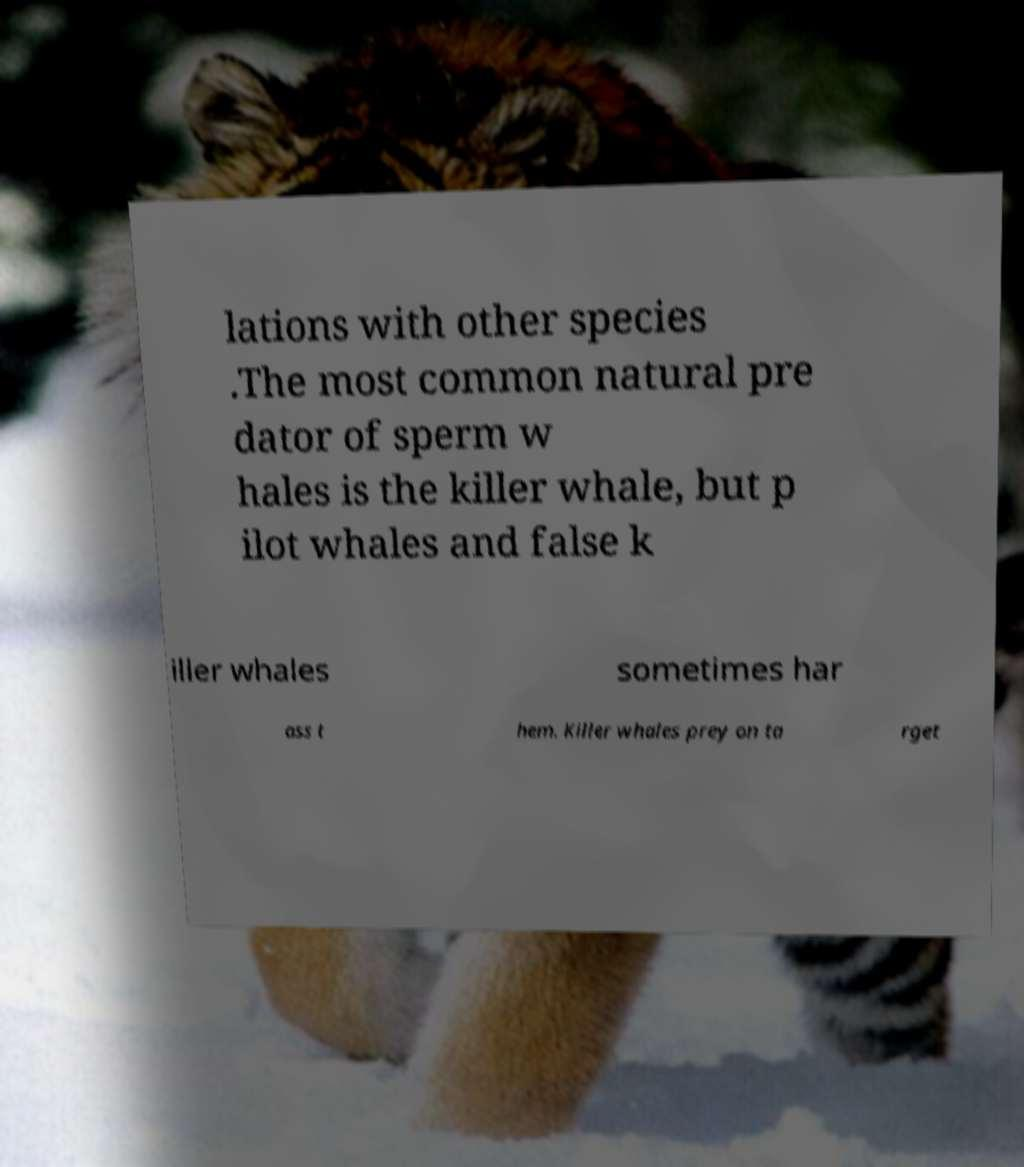What messages or text are displayed in this image? I need them in a readable, typed format. lations with other species .The most common natural pre dator of sperm w hales is the killer whale, but p ilot whales and false k iller whales sometimes har ass t hem. Killer whales prey on ta rget 